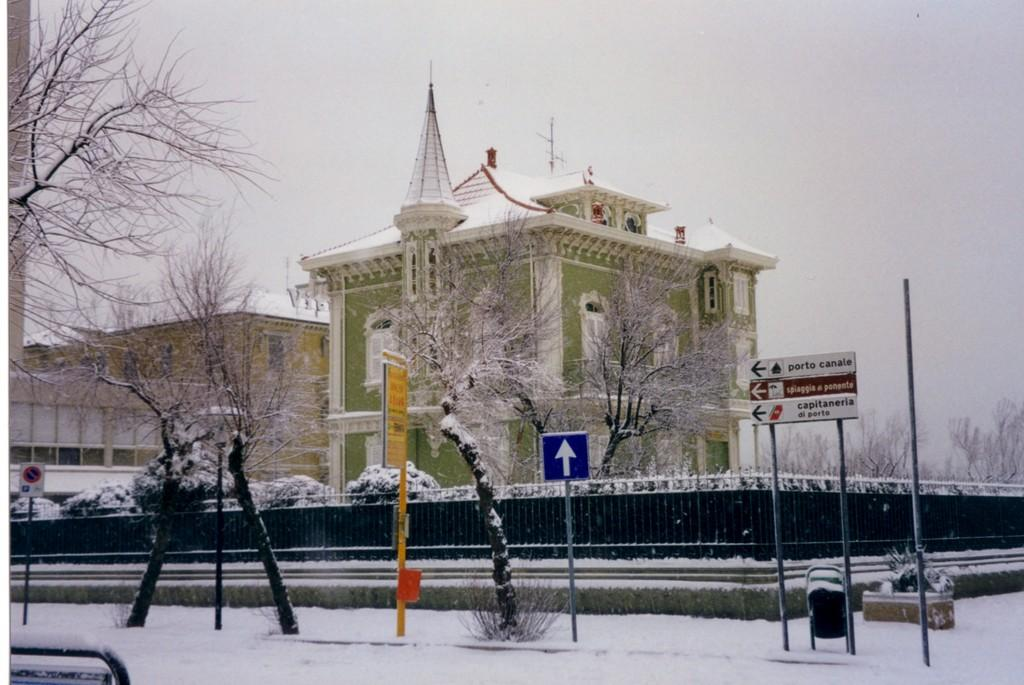What type of structures can be seen in the background of the image? There are buildings in the background of the image. What is covering the ground at the bottom of the image? There is snow at the bottom of the image. What type of vegetation is present in the image? There are trees in the image. What is the purpose of the sign board in the image? The purpose of the sign board in the image is to provide information or directions. What is visible at the top of the image? The sky is visible at the top of the image. What type of card is being used as bait in the image? There is no card or bait present in the image. What fact can be learned about the trees in the image? The provided facts do not include any specific information about the trees, so we cannot determine a fact about them from the image. 